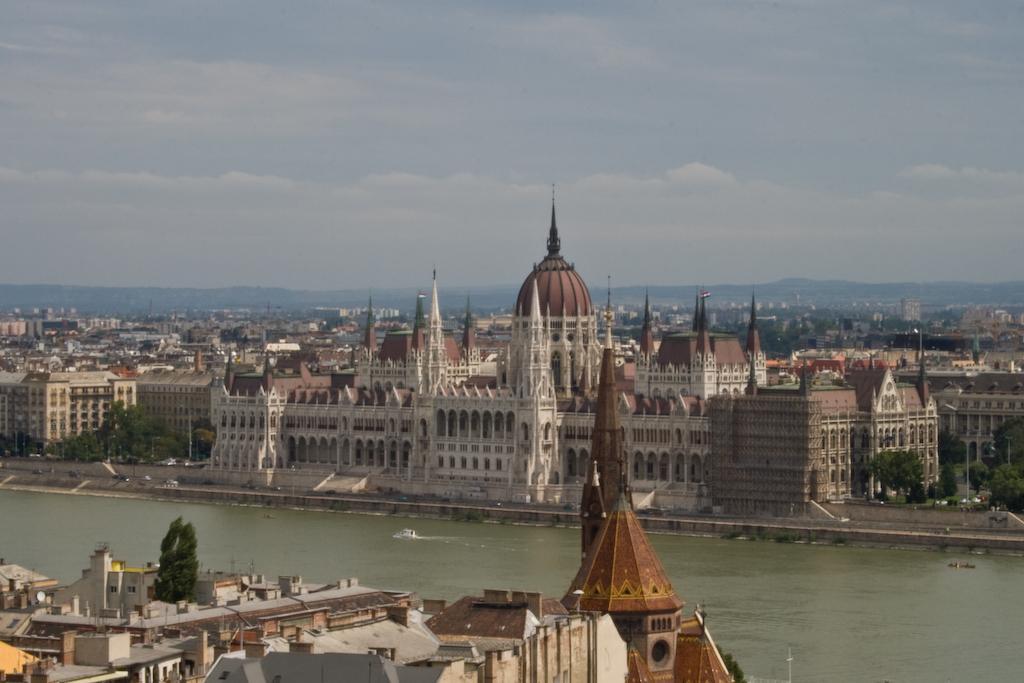Could you give a brief overview of what you see in this image? This is an outside view. At the bottom there is a sea and I can see a boat on the water. In the middle of the image there are many buildings and trees. At the top of the image I can see the sky and clouds. 